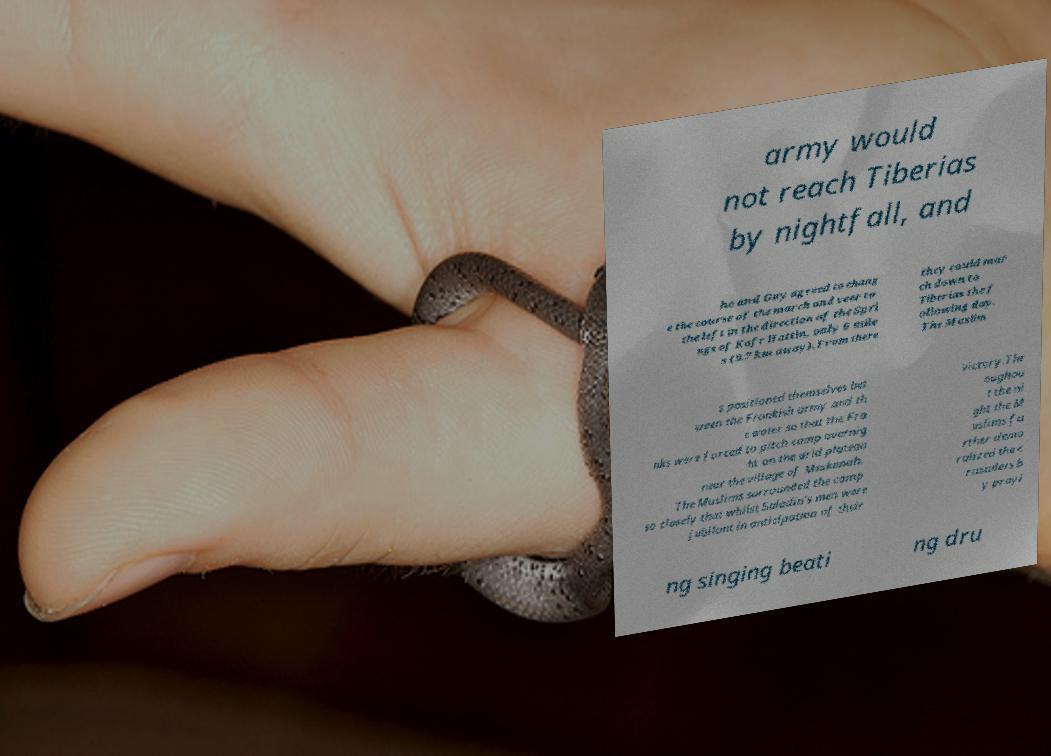I need the written content from this picture converted into text. Can you do that? army would not reach Tiberias by nightfall, and he and Guy agreed to chang e the course of the march and veer to the left in the direction of the Spri ngs of Kafr Hattin, only 6 mile s (9.7 km away). From there they could mar ch down to Tiberias the f ollowing day. The Muslim s positioned themselves bet ween the Frankish army and th e water so that the Fra nks were forced to pitch camp overnig ht on the arid plateau near the village of Meskenah. The Muslims surrounded the camp so closely that whilst Saladin's men were jubilant in anticipation of their victory.Thr oughou t the ni ght the M uslims fu rther demo ralized the c rusaders b y prayi ng singing beati ng dru 